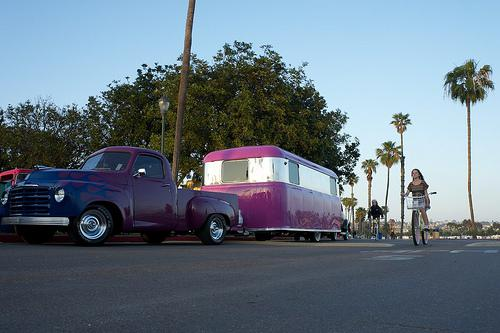Question: what color is the truck's trailer?
Choices:
A. Red.
B. Pink.
C. Green.
D. Yellow.
Answer with the letter. Answer: B Question: how many windows are visible on the truck's trailer?
Choices:
A. Four.
B. Two.
C. One.
D. Three.
Answer with the letter. Answer: D Question: what color is the truck?
Choices:
A. Purple.
B. Blue.
C. Red.
D. Black.
Answer with the letter. Answer: A Question: when was this photo taken?
Choices:
A. At midnight.
B. At evening.
C. At dawn.
D. Outside, during the daytime.
Answer with the letter. Answer: D 